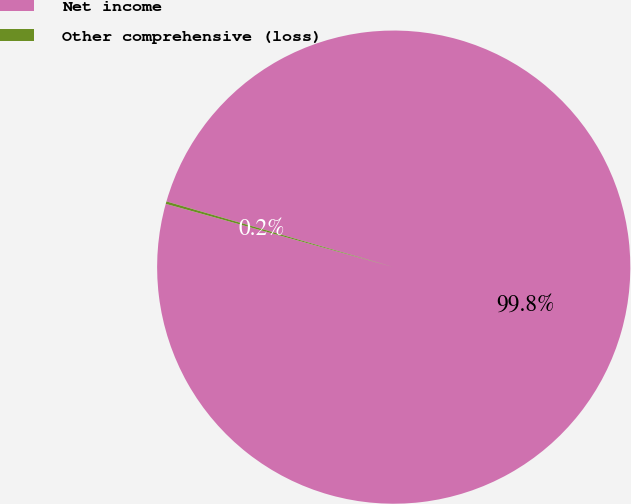Convert chart. <chart><loc_0><loc_0><loc_500><loc_500><pie_chart><fcel>Net income<fcel>Other comprehensive (loss)<nl><fcel>99.83%<fcel>0.17%<nl></chart> 